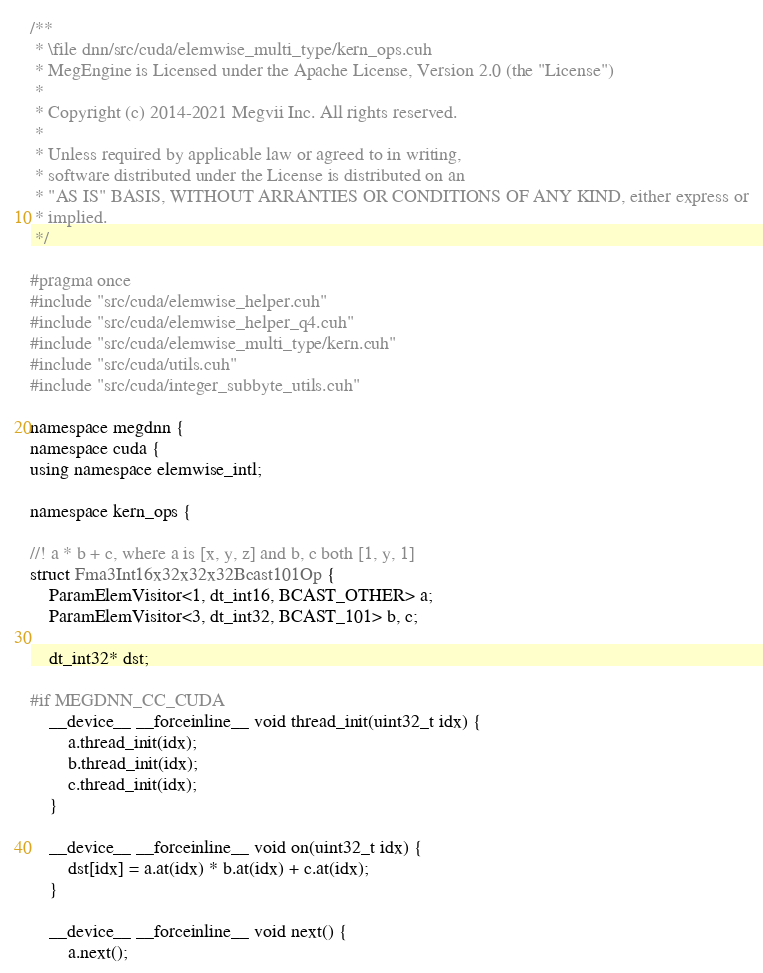Convert code to text. <code><loc_0><loc_0><loc_500><loc_500><_Cuda_>/**
 * \file dnn/src/cuda/elemwise_multi_type/kern_ops.cuh
 * MegEngine is Licensed under the Apache License, Version 2.0 (the "License")
 *
 * Copyright (c) 2014-2021 Megvii Inc. All rights reserved.
 *
 * Unless required by applicable law or agreed to in writing,
 * software distributed under the License is distributed on an
 * "AS IS" BASIS, WITHOUT ARRANTIES OR CONDITIONS OF ANY KIND, either express or
 * implied.
 */

#pragma once
#include "src/cuda/elemwise_helper.cuh"
#include "src/cuda/elemwise_helper_q4.cuh"
#include "src/cuda/elemwise_multi_type/kern.cuh"
#include "src/cuda/utils.cuh"
#include "src/cuda/integer_subbyte_utils.cuh"

namespace megdnn {
namespace cuda {
using namespace elemwise_intl;

namespace kern_ops {

//! a * b + c, where a is [x, y, z] and b, c both [1, y, 1]
struct Fma3Int16x32x32x32Bcast101Op {
    ParamElemVisitor<1, dt_int16, BCAST_OTHER> a;
    ParamElemVisitor<3, dt_int32, BCAST_101> b, c;

    dt_int32* dst;

#if MEGDNN_CC_CUDA
    __device__ __forceinline__ void thread_init(uint32_t idx) {
        a.thread_init(idx);
        b.thread_init(idx);
        c.thread_init(idx);
    }

    __device__ __forceinline__ void on(uint32_t idx) {
        dst[idx] = a.at(idx) * b.at(idx) + c.at(idx);
    }

    __device__ __forceinline__ void next() {
        a.next();</code> 